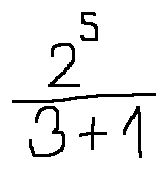Convert formula to latex. <formula><loc_0><loc_0><loc_500><loc_500>\frac { 2 ^ { 5 } } { 3 + 1 }</formula> 